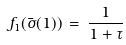<formula> <loc_0><loc_0><loc_500><loc_500>f _ { 1 } ( \bar { \sigma } ( 1 ) ) \, = \, \frac { 1 } { 1 + \tau }</formula> 